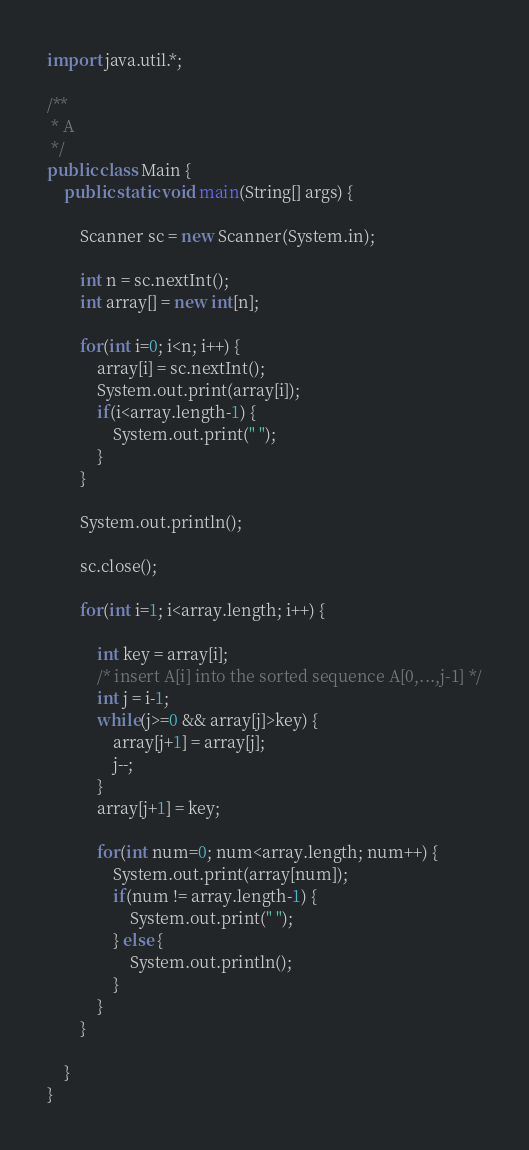<code> <loc_0><loc_0><loc_500><loc_500><_Java_>import java.util.*;

/**
 * A
 */
public class Main {
    public static void main(String[] args) {

        Scanner sc = new Scanner(System.in);

        int n = sc.nextInt();
        int array[] = new int[n];

        for(int i=0; i<n; i++) {
            array[i] = sc.nextInt();
            System.out.print(array[i]);
            if(i<array.length-1) {
                System.out.print(" ");
            }
        }

        System.out.println();

        sc.close();

        for(int i=1; i<array.length; i++) {
            
            int key = array[i];
            /* insert A[i] into the sorted sequence A[0,...,j-1] */
            int j = i-1;
            while(j>=0 && array[j]>key) {
                array[j+1] = array[j];
                j--;
            }
            array[j+1] = key;

            for(int num=0; num<array.length; num++) {
                System.out.print(array[num]);
                if(num != array.length-1) {
                    System.out.print(" ");
                } else {
                    System.out.println();
                }
            }
        }

    }
}
</code> 